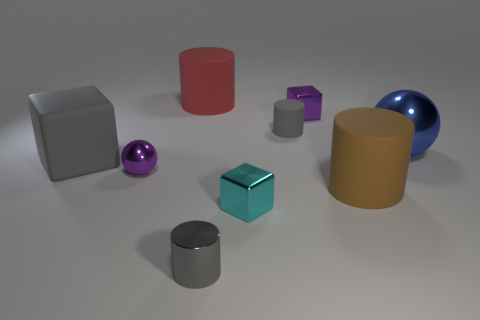What number of matte things are the same color as the tiny metallic cylinder?
Offer a terse response. 2. What is the material of the block that is in front of the purple metallic ball to the left of the blue metal sphere?
Your answer should be compact. Metal. There is a cube behind the big metallic object that is behind the shiny ball that is in front of the blue metal object; what is its size?
Give a very brief answer. Small. There is a blue object; does it have the same shape as the gray matte object behind the large metallic sphere?
Your answer should be very brief. No. What is the purple sphere made of?
Keep it short and to the point. Metal. How many rubber things are big blue balls or brown things?
Give a very brief answer. 1. Are there fewer large cubes that are right of the brown cylinder than rubber objects that are behind the big gray matte object?
Your answer should be compact. Yes. Is there a big brown matte object in front of the small purple thing right of the small metallic block that is in front of the large gray thing?
Provide a short and direct response. Yes. There is a big object that is the same color as the small rubber cylinder; what is it made of?
Ensure brevity in your answer.  Rubber. There is a purple metallic thing to the left of the purple block; is it the same shape as the big thing on the right side of the large brown matte object?
Offer a very short reply. Yes. 